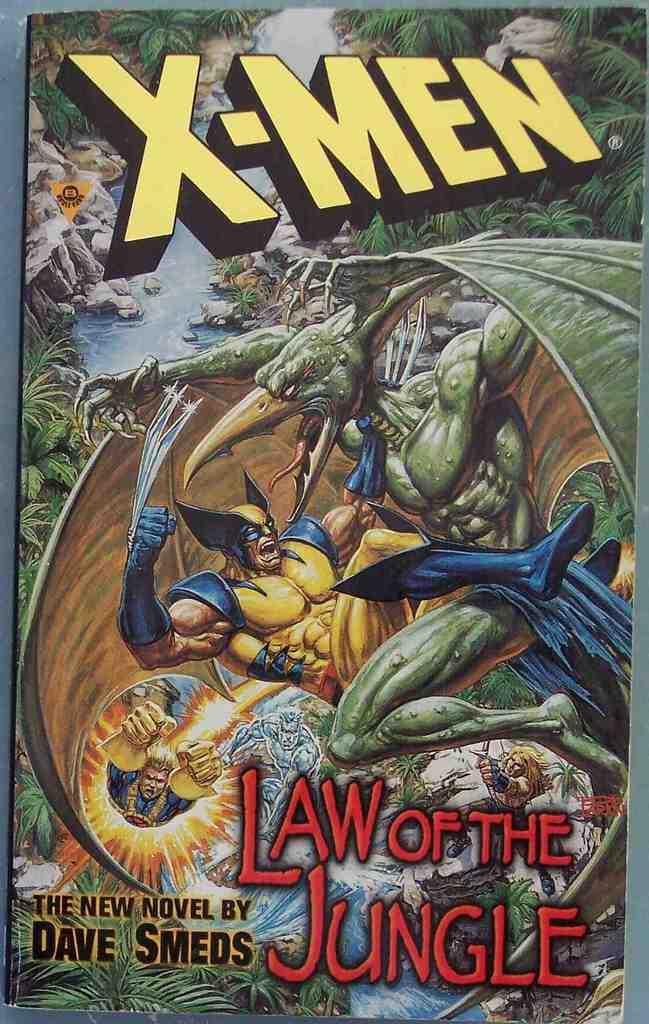In one or two sentences, can you explain what this image depicts? In this picture I can see there is a cover page, there are images of man, bird and there are rocks, river and there are plants. 